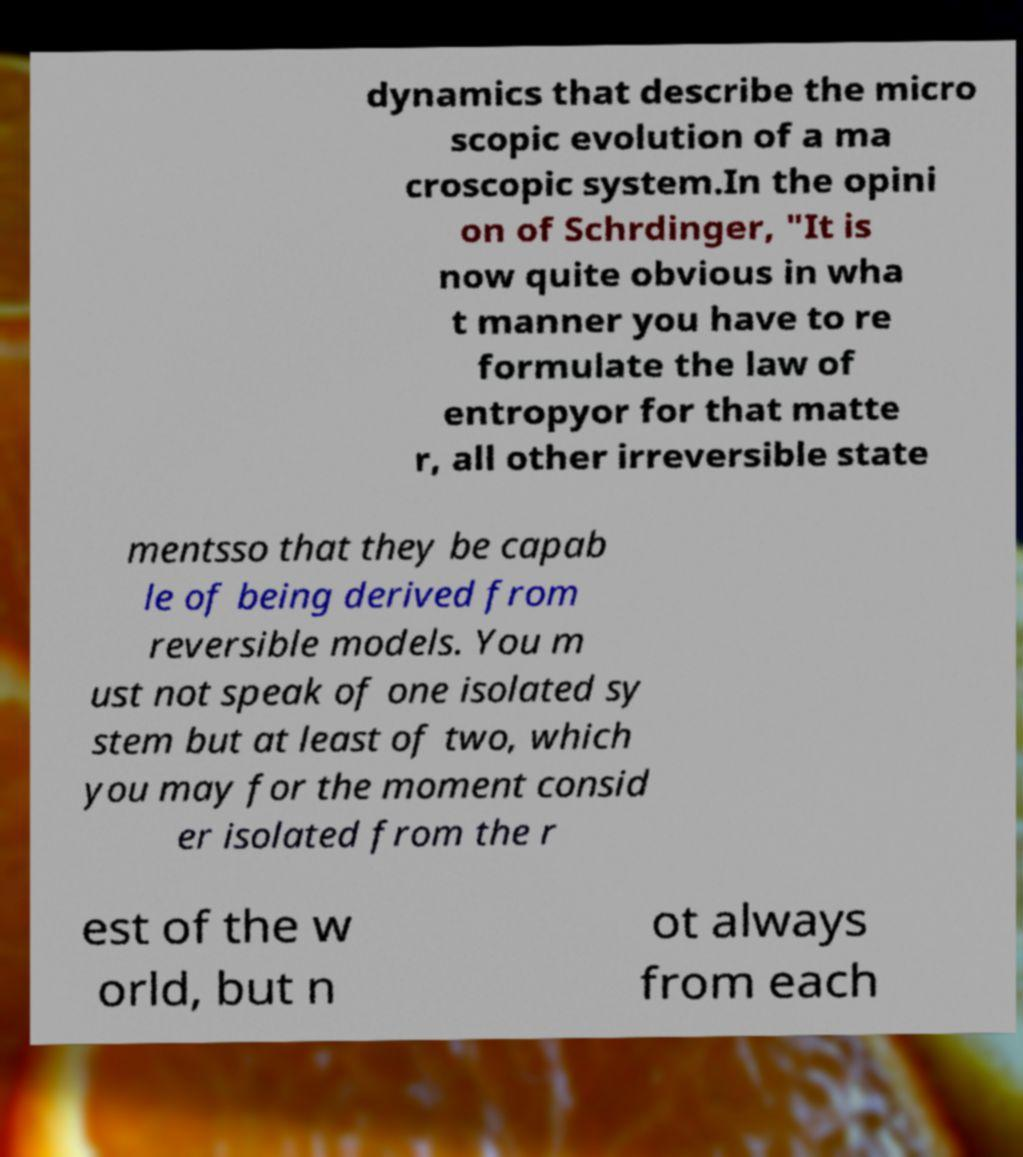Please read and relay the text visible in this image. What does it say? dynamics that describe the micro scopic evolution of a ma croscopic system.In the opini on of Schrdinger, "It is now quite obvious in wha t manner you have to re formulate the law of entropyor for that matte r, all other irreversible state mentsso that they be capab le of being derived from reversible models. You m ust not speak of one isolated sy stem but at least of two, which you may for the moment consid er isolated from the r est of the w orld, but n ot always from each 